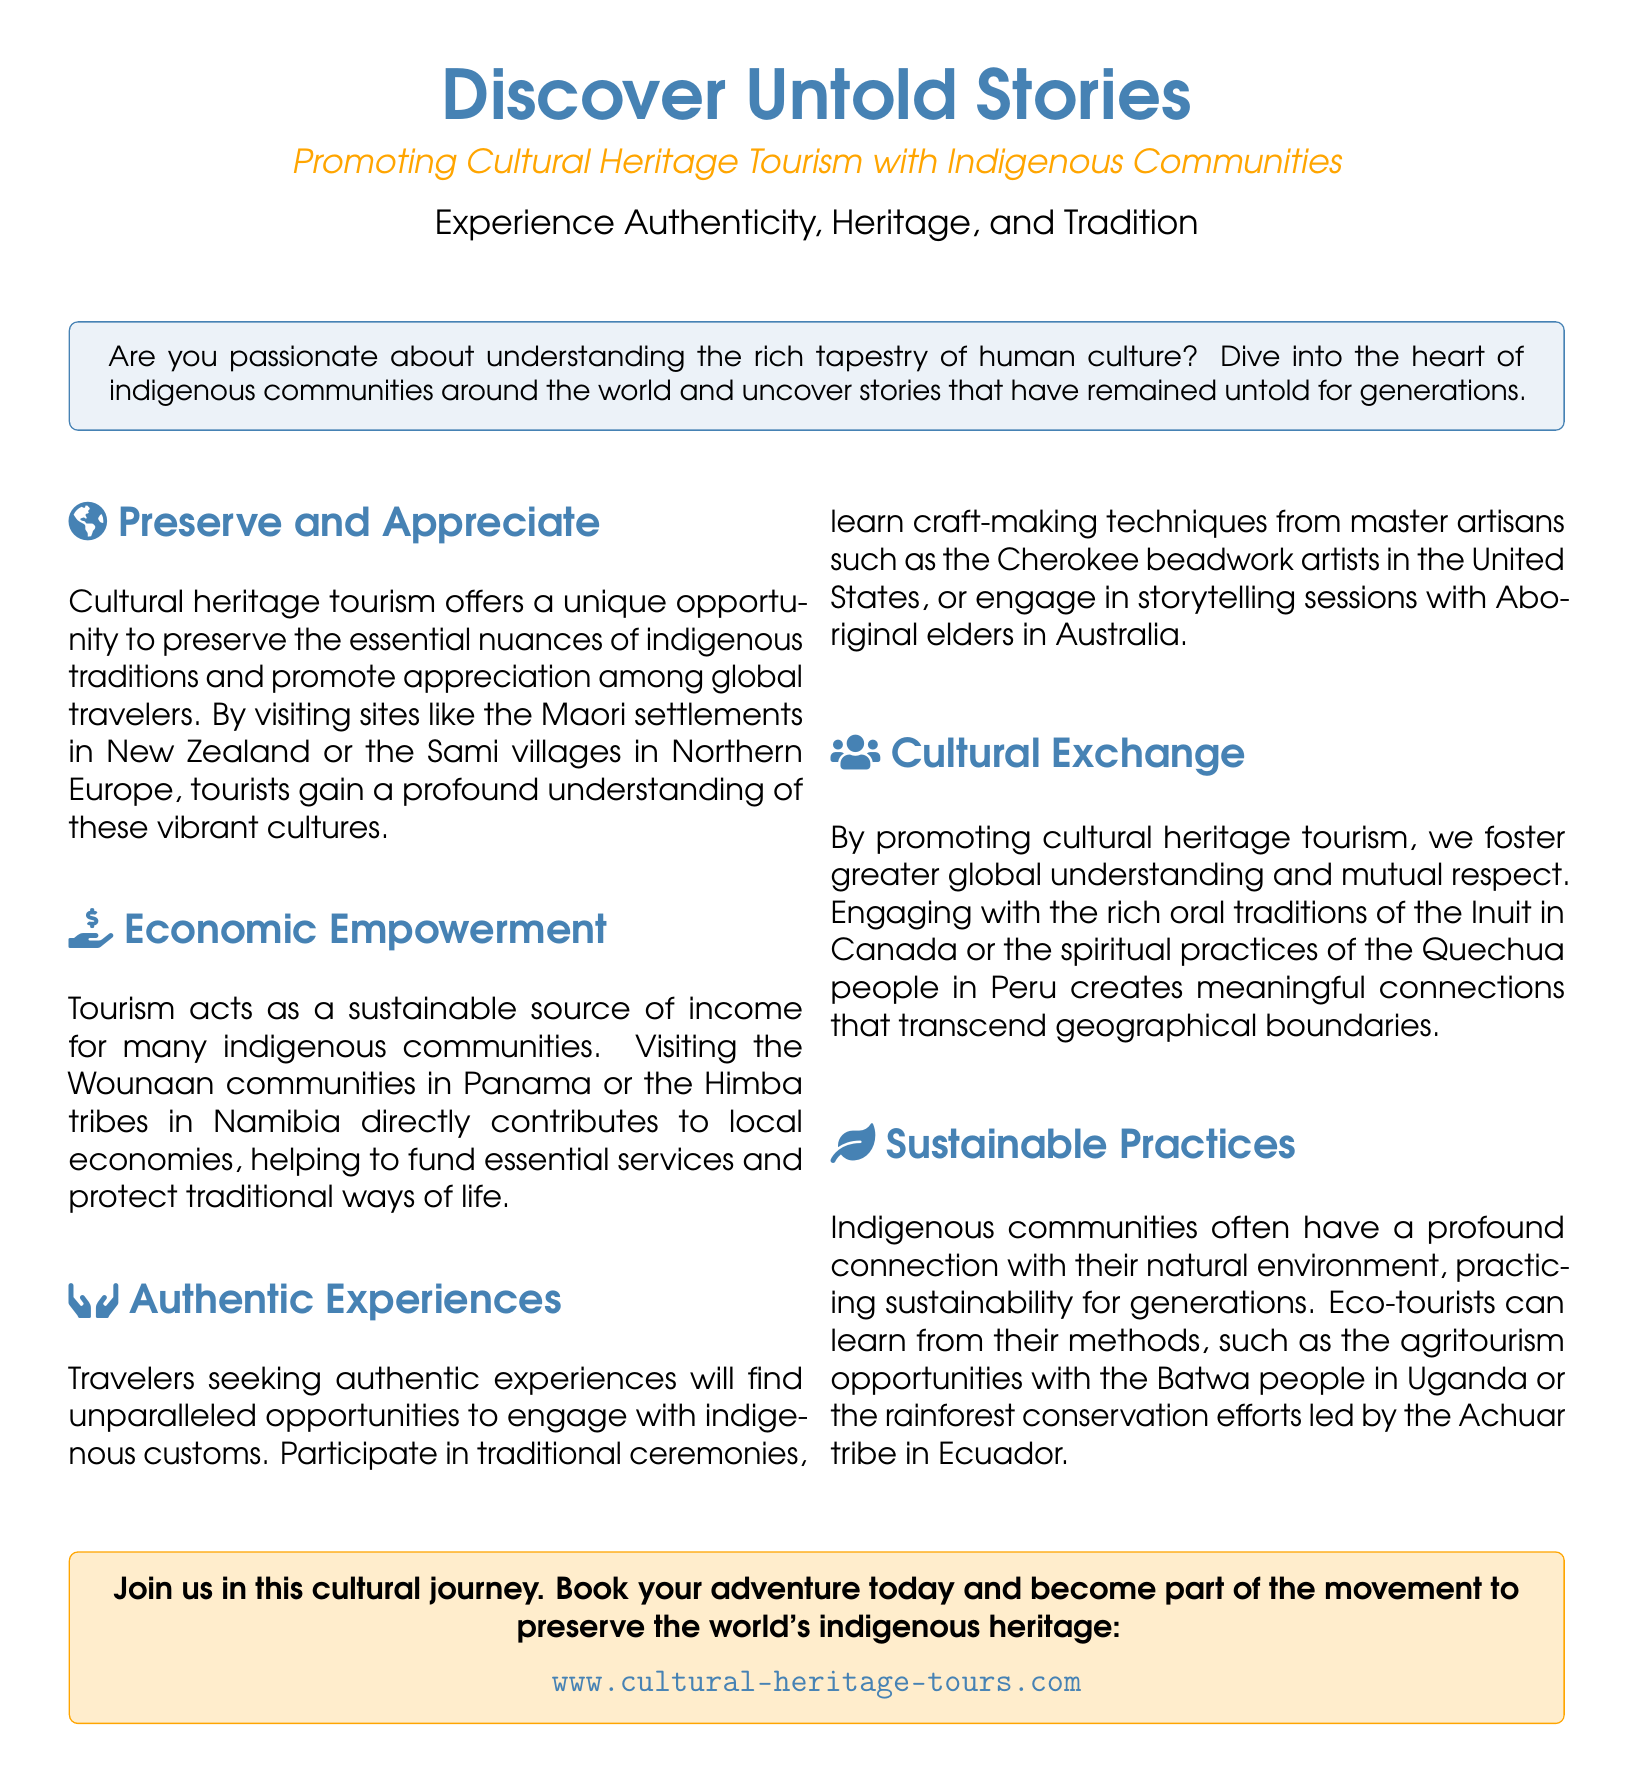What is the title of the advertisement? The title is prominently displayed in the document, which is "Discover Untold Stories."
Answer: Discover Untold Stories What type of tourism is being promoted? The document focuses on a specific type of tourism that is highlighted in the subtitle.
Answer: Cultural Heritage Tourism Which indigenous community is mentioned as an example in New Zealand? The document provides a specific example of a community in New Zealand related to cultural heritage tourism.
Answer: Maori What economic benefit does tourism provide to indigenous communities? The advertisement discusses the impact of tourism on indigenous communities, specifically in terms of financial gain.
Answer: Sustainable source of income What unique experiences can travelers participate in according to the advertisement? The document outlines various activities travelers can engage in to immerse themselves in indigenous cultures.
Answer: Traditional ceremonies Which indigenous people's oral traditions are mentioned in the document? The advertisement refers to specific indigenous groups whose oral traditions are highlighted as an aspect of cultural exchange.
Answer: Inuit What is the website mentioned for booking adventures? The advertisement concludes with a call to action that includes a specific website for obtaining more information.
Answer: www.cultural-heritage-tours.com What kind of practices do indigenous communities often engage in, as stated in the document? The advertisement describes a particular theme regarding the relationship between indigenous communities and their environment.
Answer: Sustainable practices In which country are the Himba tribes located? The document provides a geographical reference to the Himba tribes, specifying their location on the world map.
Answer: Namibia 